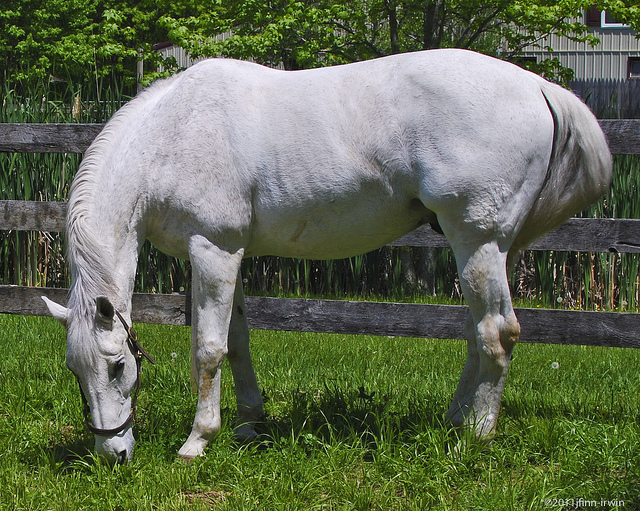Can you describe the surroundings of the horse? The horse stands in a lush, green grassy field that is bordered by a wooden fence. Behind this fence, there is tall greenery, possibly reeds or tall grasses, giving the scene a natural and serene atmosphere. 